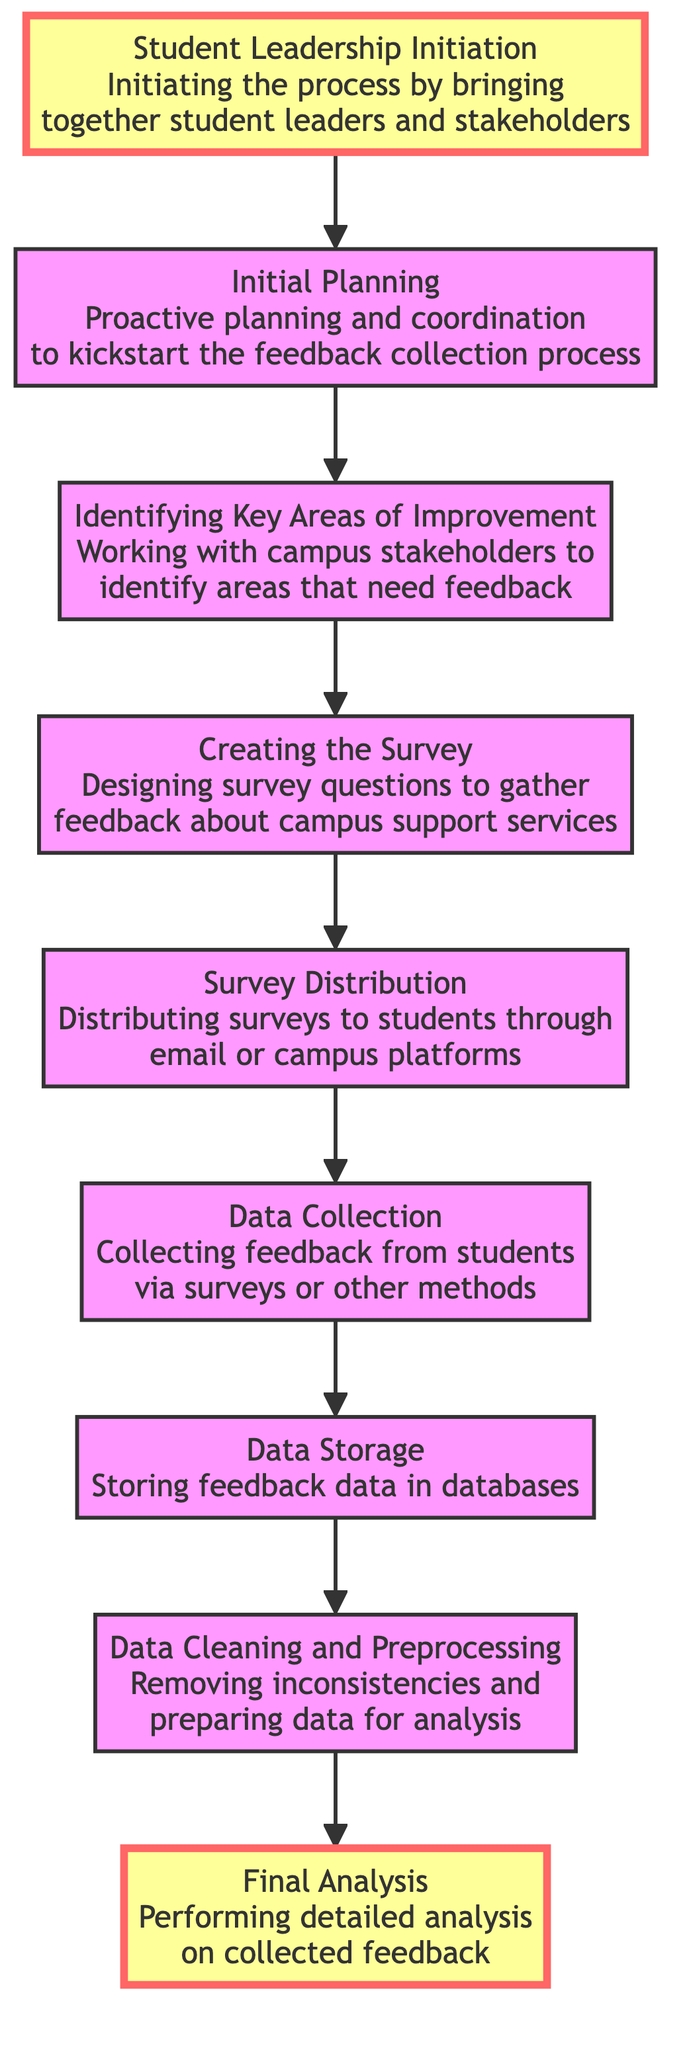What is the last step in the flowchart? The final step in the flowchart is indicated as "Final Analysis", which comes after the "Data Cleaning and Preprocessing" step. This is derived from the flow sequence provided in the diagram.
Answer: Final Analysis How many steps are in the feedback collection process? By counting the elements listed in the flowchart, we see there are eight steps from "Student Leadership Initiation" to "Final Analysis".
Answer: Eight What element comes right before "Data Storage"? According to the flowchart, the element preceding "Data Storage" is "Data Collection", as the arrows show the progression from "Data Collection" to "Data Storage".
Answer: Data Collection What do you do during the "Creating the Survey" phase? The phase of "Creating the Survey" involves designing survey questions to gather feedback. This is specifically stated in the description associated with that flowchart element.
Answer: Designing survey questions What is the connection between "Initial Planning" and "Identifying Key Areas of Improvement"? "Initial Planning" directly leads to "Identifying Key Areas of Improvement", indicating that proper planning is essential to determine the areas where feedback is needed. This can be observed through the arrows connecting these two nodes in the flowchart.
Answer: Direct connection Which step involves working with campus stakeholders? The "Identifying Key Areas of Improvement" step entails collaboration with campus stakeholders to find areas that require feedback, which is explicitly noted in the description of that element.
Answer: Identifying Key Areas of Improvement What is the first step in the feedback process? The first step is "Student Leadership Initiation", which serves as the starting point for the feedback collection process according to the flow of the diagram.
Answer: Student Leadership Initiation What is the purpose of the "Data Cleaning and Preprocessing" step? The purpose of the "Data Cleaning and Preprocessing" step is to remove inconsistencies and prepare the collected data for the subsequent analysis, as described in that node of the flowchart.
Answer: Removing inconsistencies 